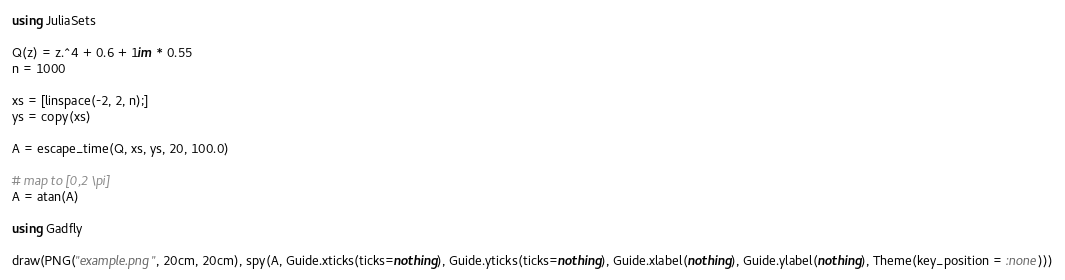Convert code to text. <code><loc_0><loc_0><loc_500><loc_500><_Julia_>using JuliaSets

Q(z) = z.^4 + 0.6 + 1im * 0.55
n = 1000

xs = [linspace(-2, 2, n);]
ys = copy(xs)

A = escape_time(Q, xs, ys, 20, 100.0)

# map to [0,2 \pi]
A = atan(A)

using Gadfly

draw(PNG("example.png", 20cm, 20cm), spy(A, Guide.xticks(ticks=nothing), Guide.yticks(ticks=nothing), Guide.xlabel(nothing), Guide.ylabel(nothing), Theme(key_position = :none)))
</code> 